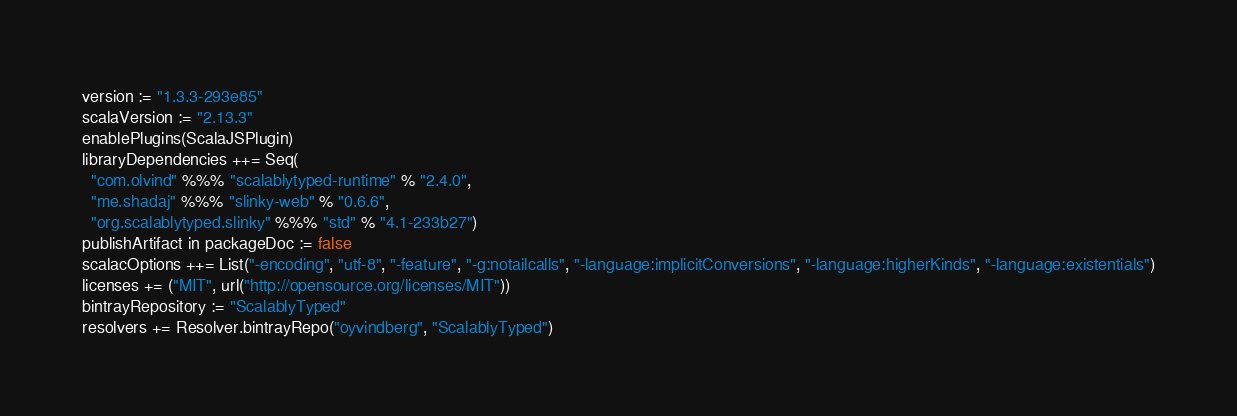<code> <loc_0><loc_0><loc_500><loc_500><_Scala_>version := "1.3.3-293e85"
scalaVersion := "2.13.3"
enablePlugins(ScalaJSPlugin)
libraryDependencies ++= Seq(
  "com.olvind" %%% "scalablytyped-runtime" % "2.4.0",
  "me.shadaj" %%% "slinky-web" % "0.6.6",
  "org.scalablytyped.slinky" %%% "std" % "4.1-233b27")
publishArtifact in packageDoc := false
scalacOptions ++= List("-encoding", "utf-8", "-feature", "-g:notailcalls", "-language:implicitConversions", "-language:higherKinds", "-language:existentials")
licenses += ("MIT", url("http://opensource.org/licenses/MIT"))
bintrayRepository := "ScalablyTyped"
resolvers += Resolver.bintrayRepo("oyvindberg", "ScalablyTyped")
</code> 